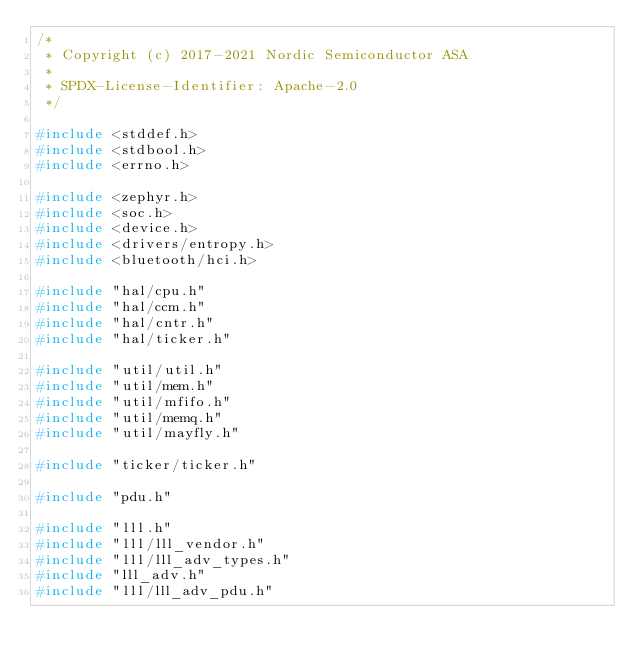Convert code to text. <code><loc_0><loc_0><loc_500><loc_500><_C_>/*
 * Copyright (c) 2017-2021 Nordic Semiconductor ASA
 *
 * SPDX-License-Identifier: Apache-2.0
 */

#include <stddef.h>
#include <stdbool.h>
#include <errno.h>

#include <zephyr.h>
#include <soc.h>
#include <device.h>
#include <drivers/entropy.h>
#include <bluetooth/hci.h>

#include "hal/cpu.h"
#include "hal/ccm.h"
#include "hal/cntr.h"
#include "hal/ticker.h"

#include "util/util.h"
#include "util/mem.h"
#include "util/mfifo.h"
#include "util/memq.h"
#include "util/mayfly.h"

#include "ticker/ticker.h"

#include "pdu.h"

#include "lll.h"
#include "lll/lll_vendor.h"
#include "lll/lll_adv_types.h"
#include "lll_adv.h"
#include "lll/lll_adv_pdu.h"</code> 